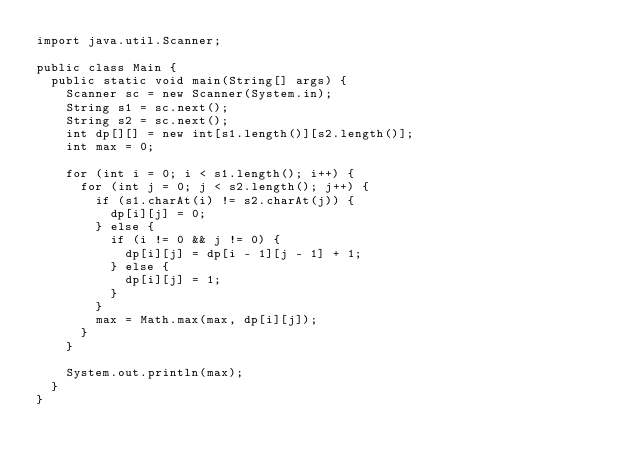<code> <loc_0><loc_0><loc_500><loc_500><_Java_>import java.util.Scanner;

public class Main {
	public static void main(String[] args) {
		Scanner sc = new Scanner(System.in);
		String s1 = sc.next();
		String s2 = sc.next();
		int dp[][] = new int[s1.length()][s2.length()];
		int max = 0;
		
		for (int i = 0; i < s1.length(); i++) {
			for (int j = 0; j < s2.length(); j++) {
				if (s1.charAt(i) != s2.charAt(j)) {
					dp[i][j] = 0;
				} else {
					if (i != 0 && j != 0) {
						dp[i][j] = dp[i - 1][j - 1] + 1;
					} else {
						dp[i][j] = 1;
					}
				}
				max = Math.max(max, dp[i][j]);
			}
		}
		
		System.out.println(max);
	}
}</code> 